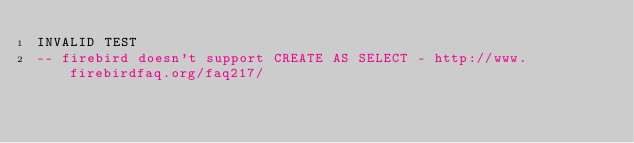Convert code to text. <code><loc_0><loc_0><loc_500><loc_500><_SQL_>INVALID TEST
-- firebird doesn't support CREATE AS SELECT - http://www.firebirdfaq.org/faq217/</code> 